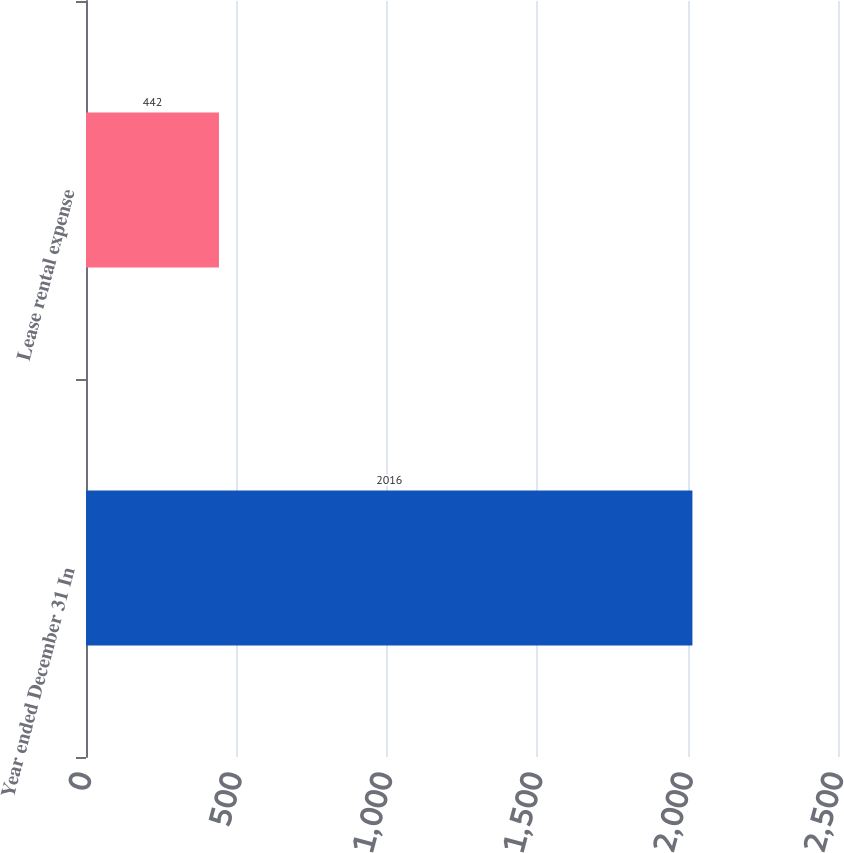Convert chart. <chart><loc_0><loc_0><loc_500><loc_500><bar_chart><fcel>Year ended December 31 In<fcel>Lease rental expense<nl><fcel>2016<fcel>442<nl></chart> 